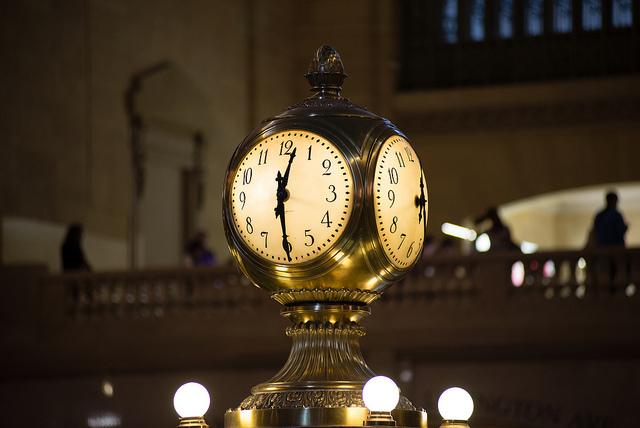What is the time?
Short answer required. 12:30. How much longer until midnight?
Short answer required. 23 hours 30 minutes. What time is it?
Give a very brief answer. 12:30. Are both clocks showing the same time?
Short answer required. Yes. What time is shown  on the clock?
Give a very brief answer. 12:30. How many round white lights are beneath the clocks?
Be succinct. 3. 